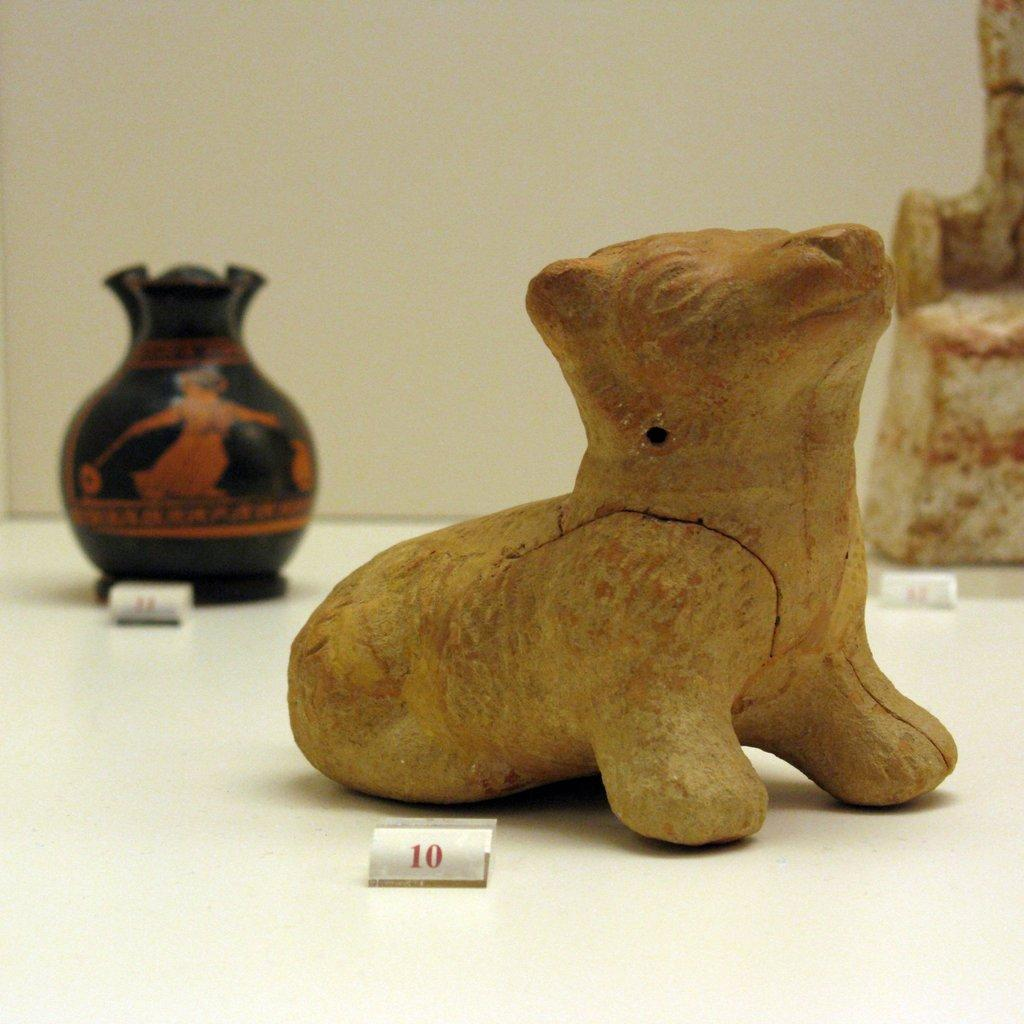What can be seen on the surface in the image? There are decorations on a surface in the image. What else is present on the surface with the decorations? There is a piece of paper with numbers in the image. How are the decorations and the piece of paper arranged in relation to each other? The piece of paper is placed beside the decorations. What can be seen in the background of the image? There is a wall visible in the image. What type of toys are present in the image? There are no toys present in the image. What event is being celebrated in the image? The image does not provide any information about a specific event or occasion. 